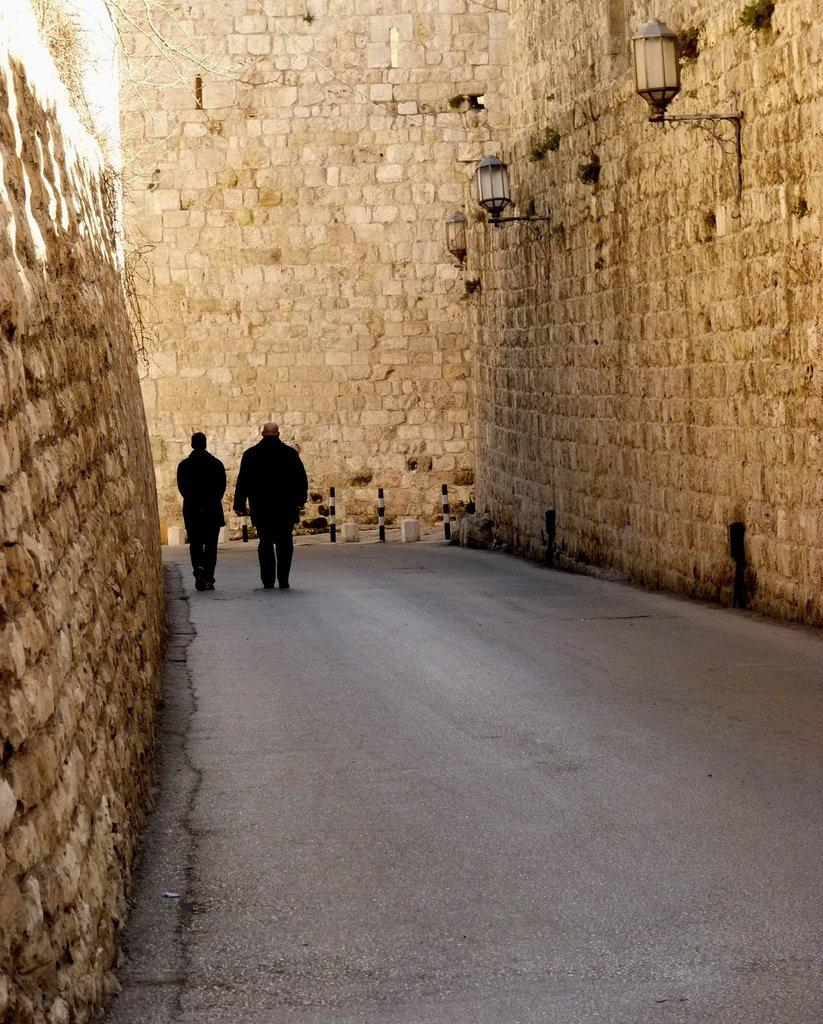How many people are in the image? There are two people in the image. Where are the people located? The people are on the road. What color are the dresses worn by the people? The people are wearing black color dresses. What is located near the people? There is a wall to the side of the people. What can be seen attached to the wall? There are lights attached to the wall. What type of gold ornaments are the people wearing in the image? There is no mention of gold ornaments in the image; the people are wearing black color dresses. Is there a plough visible in the image? No, there is no plough present in the image. 